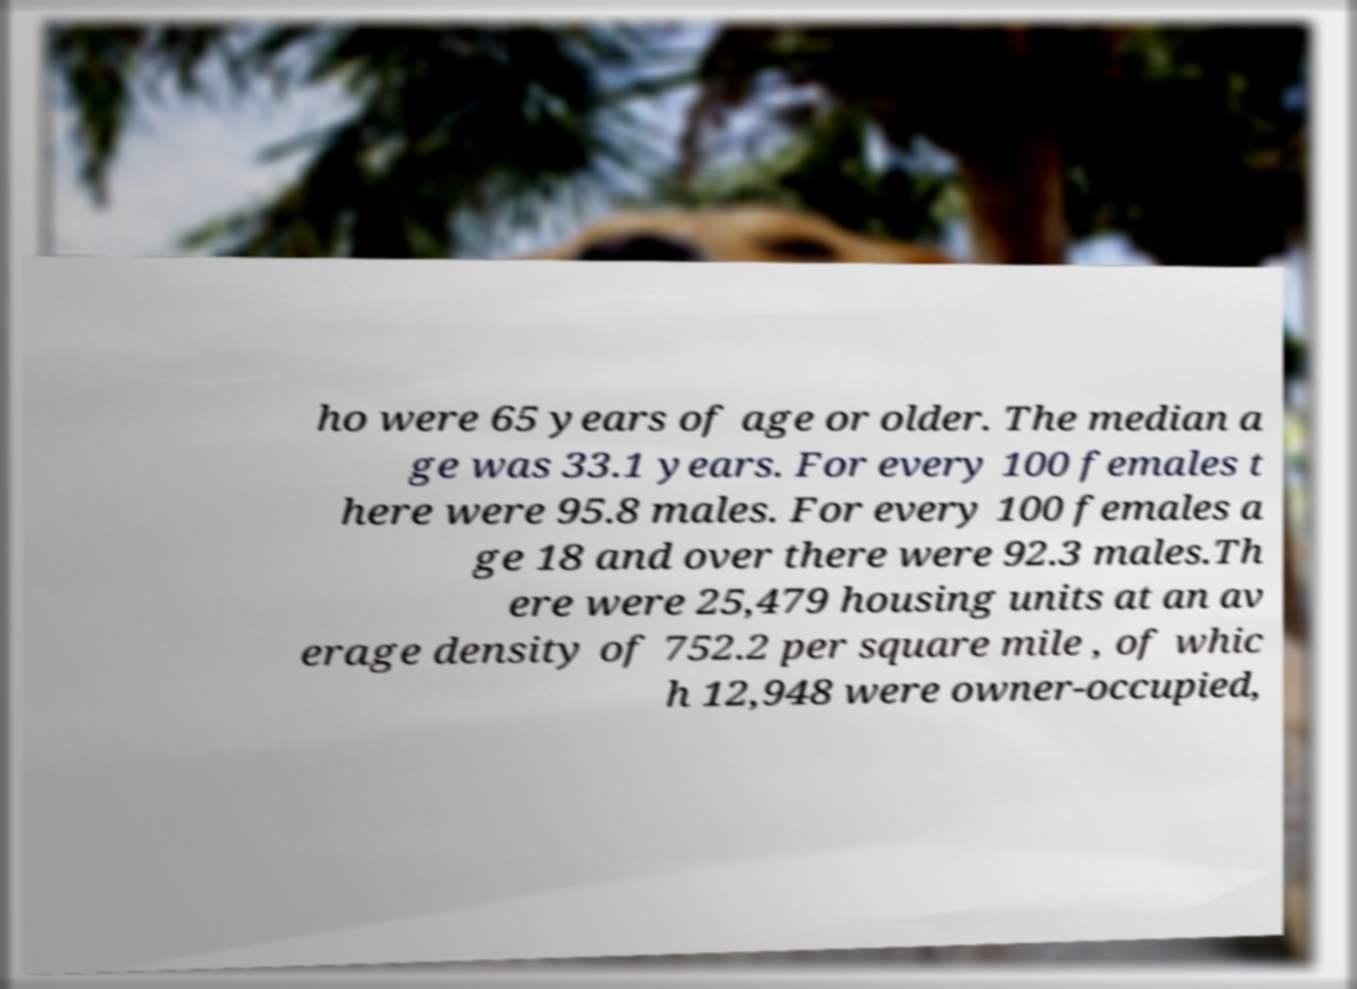Please read and relay the text visible in this image. What does it say? ho were 65 years of age or older. The median a ge was 33.1 years. For every 100 females t here were 95.8 males. For every 100 females a ge 18 and over there were 92.3 males.Th ere were 25,479 housing units at an av erage density of 752.2 per square mile , of whic h 12,948 were owner-occupied, 